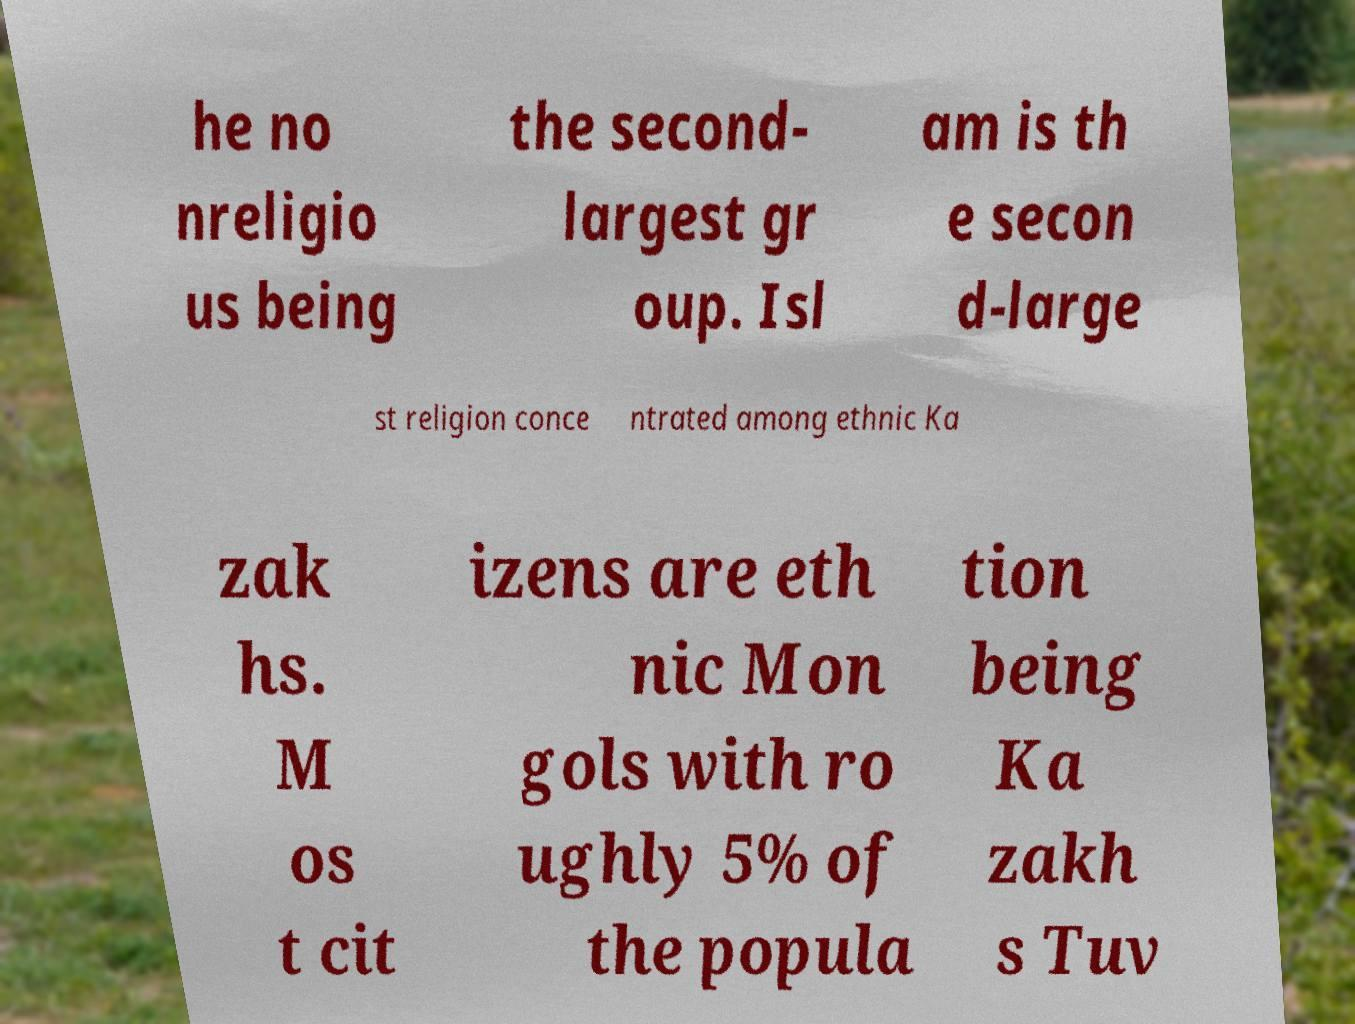There's text embedded in this image that I need extracted. Can you transcribe it verbatim? he no nreligio us being the second- largest gr oup. Isl am is th e secon d-large st religion conce ntrated among ethnic Ka zak hs. M os t cit izens are eth nic Mon gols with ro ughly 5% of the popula tion being Ka zakh s Tuv 